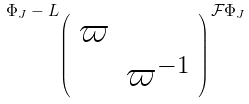<formula> <loc_0><loc_0><loc_500><loc_500>\Phi _ { J } - L _ { \left ( \begin{array} { c c } \varpi & \\ & \varpi ^ { - 1 } \end{array} \right ) } \mathcal { F } \Phi _ { J }</formula> 